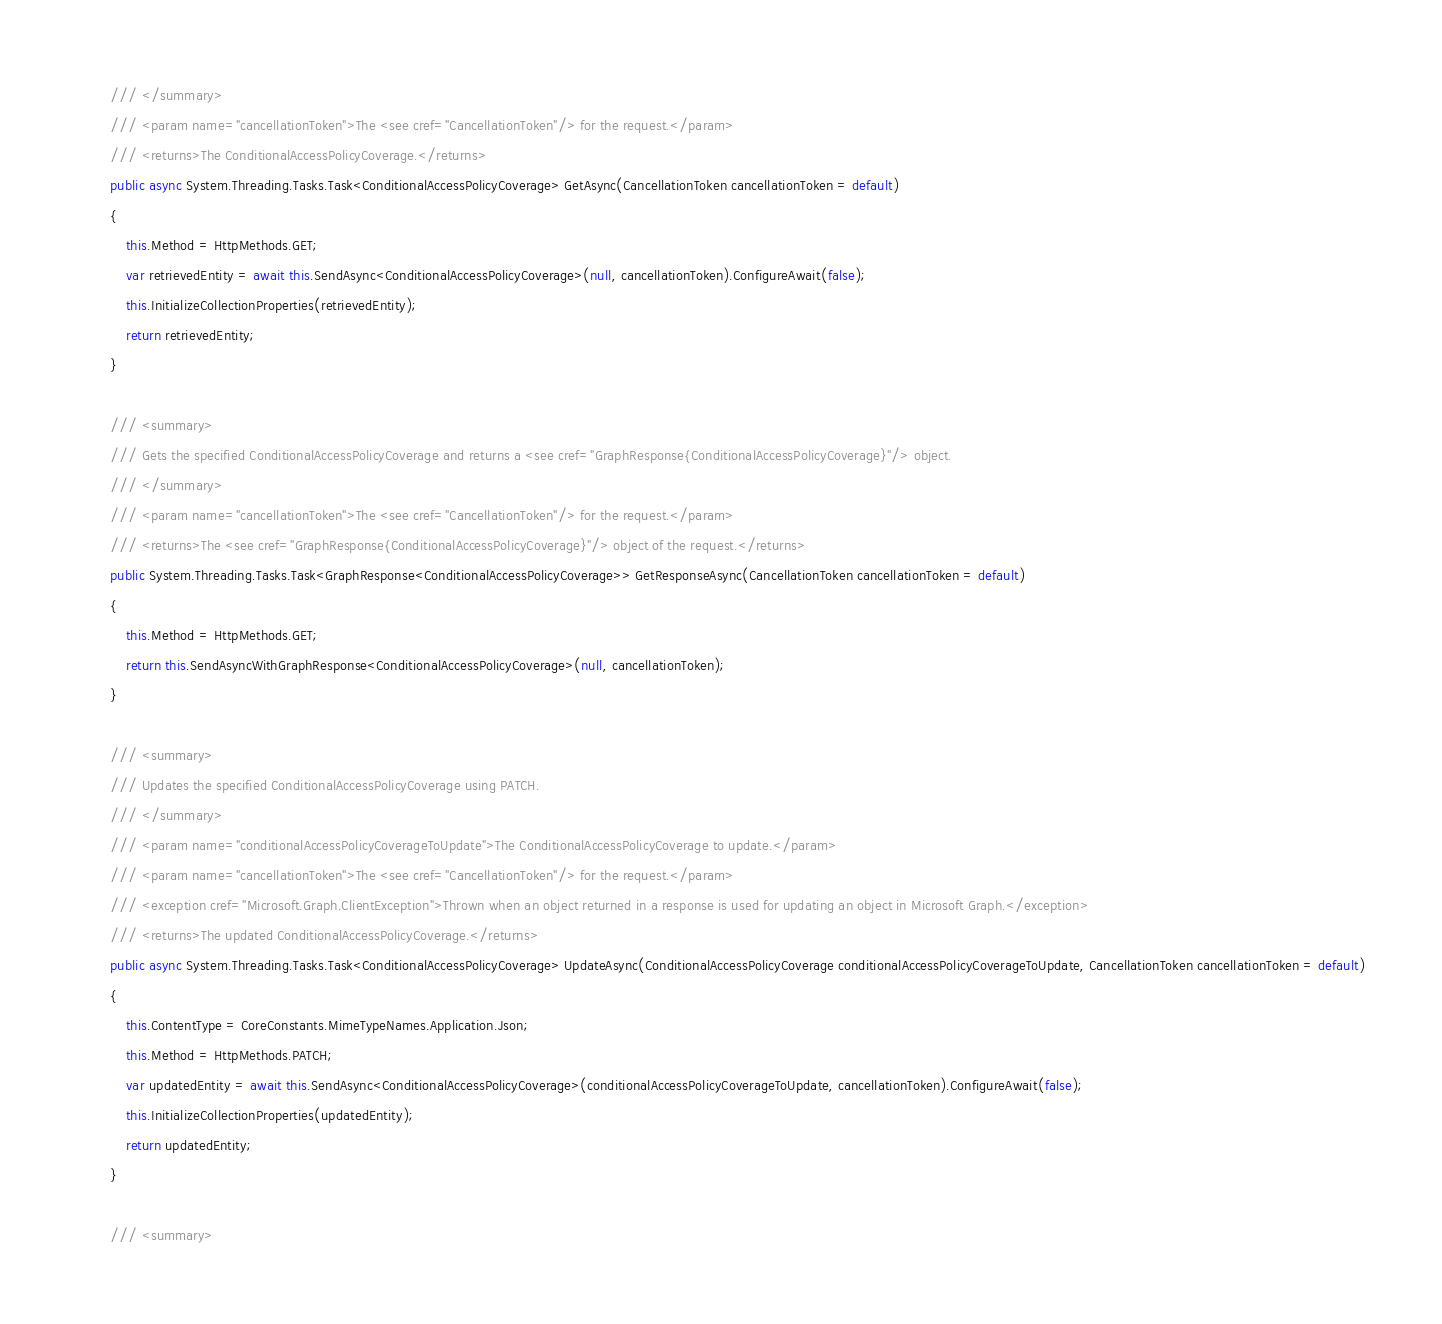<code> <loc_0><loc_0><loc_500><loc_500><_C#_>        /// </summary>
        /// <param name="cancellationToken">The <see cref="CancellationToken"/> for the request.</param>
        /// <returns>The ConditionalAccessPolicyCoverage.</returns>
        public async System.Threading.Tasks.Task<ConditionalAccessPolicyCoverage> GetAsync(CancellationToken cancellationToken = default)
        {
            this.Method = HttpMethods.GET;
            var retrievedEntity = await this.SendAsync<ConditionalAccessPolicyCoverage>(null, cancellationToken).ConfigureAwait(false);
            this.InitializeCollectionProperties(retrievedEntity);
            return retrievedEntity;
        }

        /// <summary>
        /// Gets the specified ConditionalAccessPolicyCoverage and returns a <see cref="GraphResponse{ConditionalAccessPolicyCoverage}"/> object.
        /// </summary>
        /// <param name="cancellationToken">The <see cref="CancellationToken"/> for the request.</param>
        /// <returns>The <see cref="GraphResponse{ConditionalAccessPolicyCoverage}"/> object of the request.</returns>
        public System.Threading.Tasks.Task<GraphResponse<ConditionalAccessPolicyCoverage>> GetResponseAsync(CancellationToken cancellationToken = default)
        {
            this.Method = HttpMethods.GET;
            return this.SendAsyncWithGraphResponse<ConditionalAccessPolicyCoverage>(null, cancellationToken);
        }

        /// <summary>
        /// Updates the specified ConditionalAccessPolicyCoverage using PATCH.
        /// </summary>
        /// <param name="conditionalAccessPolicyCoverageToUpdate">The ConditionalAccessPolicyCoverage to update.</param>
        /// <param name="cancellationToken">The <see cref="CancellationToken"/> for the request.</param>
        /// <exception cref="Microsoft.Graph.ClientException">Thrown when an object returned in a response is used for updating an object in Microsoft Graph.</exception>
        /// <returns>The updated ConditionalAccessPolicyCoverage.</returns>
        public async System.Threading.Tasks.Task<ConditionalAccessPolicyCoverage> UpdateAsync(ConditionalAccessPolicyCoverage conditionalAccessPolicyCoverageToUpdate, CancellationToken cancellationToken = default)
        {
            this.ContentType = CoreConstants.MimeTypeNames.Application.Json;
            this.Method = HttpMethods.PATCH;
            var updatedEntity = await this.SendAsync<ConditionalAccessPolicyCoverage>(conditionalAccessPolicyCoverageToUpdate, cancellationToken).ConfigureAwait(false);
            this.InitializeCollectionProperties(updatedEntity);
            return updatedEntity;
        }

        /// <summary></code> 